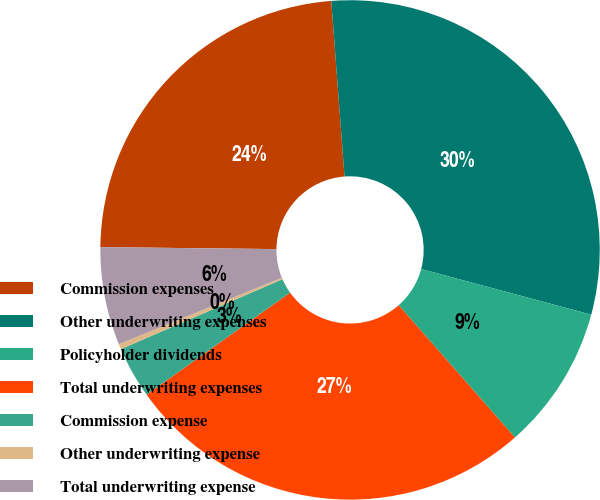<chart> <loc_0><loc_0><loc_500><loc_500><pie_chart><fcel>Commission expenses<fcel>Other underwriting expenses<fcel>Policyholder dividends<fcel>Total underwriting expenses<fcel>Commission expense<fcel>Other underwriting expense<fcel>Total underwriting expense<nl><fcel>23.62%<fcel>30.37%<fcel>9.35%<fcel>26.63%<fcel>3.34%<fcel>0.34%<fcel>6.34%<nl></chart> 